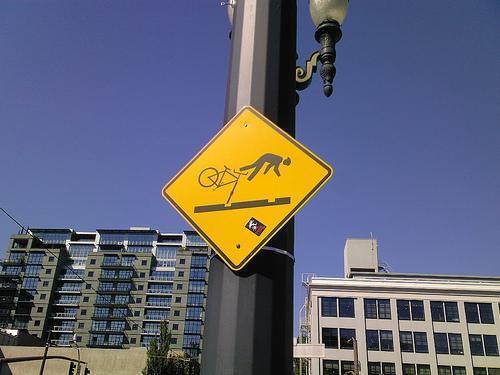How many people are wearing glasses?
Give a very brief answer. 0. 